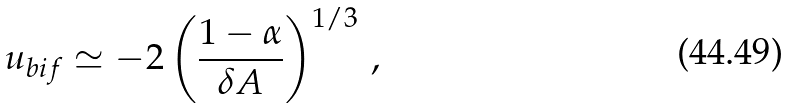Convert formula to latex. <formula><loc_0><loc_0><loc_500><loc_500>u _ { b i f } \simeq - 2 \left ( \frac { 1 - \alpha } { \delta A } \right ) ^ { 1 / 3 } \, ,</formula> 